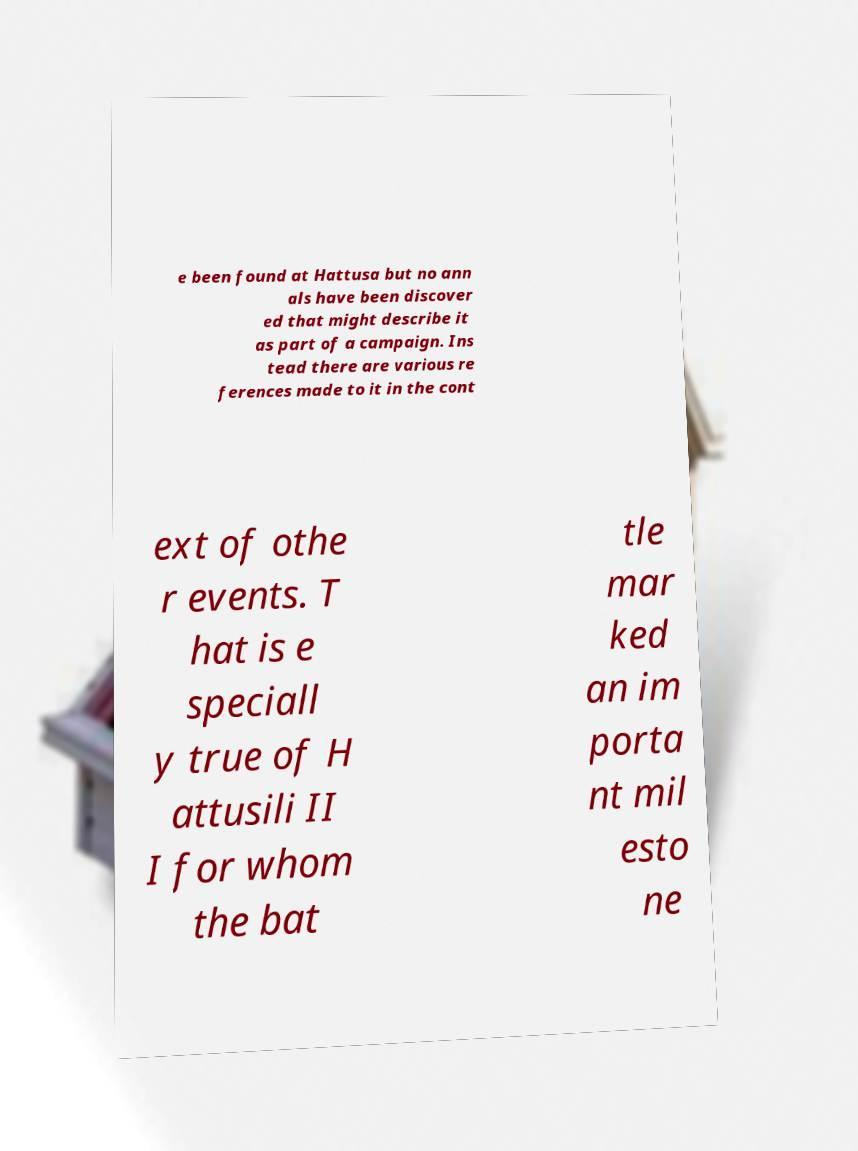Could you extract and type out the text from this image? e been found at Hattusa but no ann als have been discover ed that might describe it as part of a campaign. Ins tead there are various re ferences made to it in the cont ext of othe r events. T hat is e speciall y true of H attusili II I for whom the bat tle mar ked an im porta nt mil esto ne 